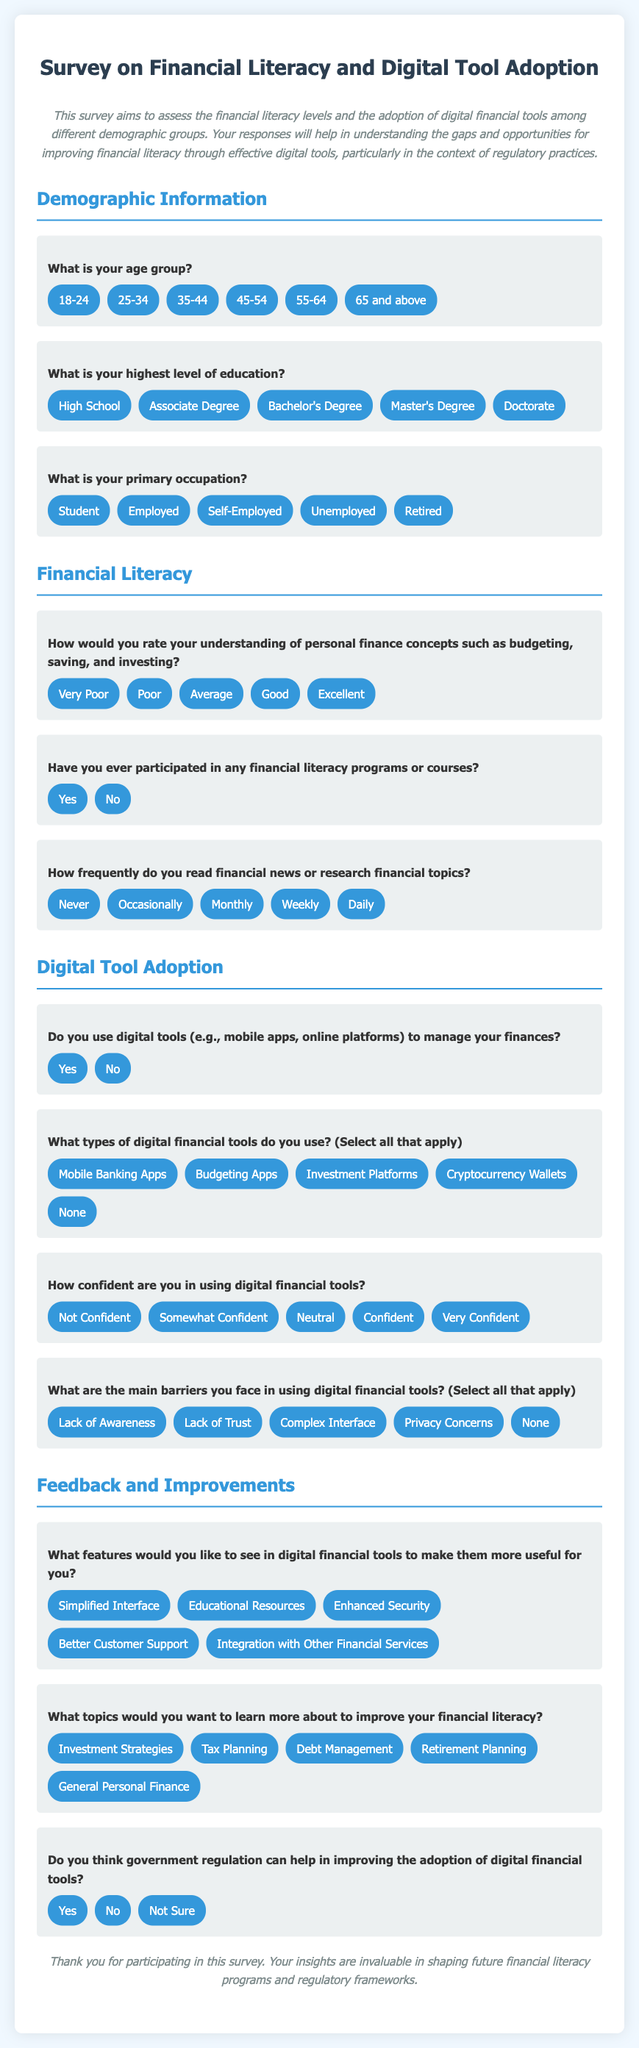What is the title of the document? The title of the document is displayed prominently at the top of the rendered survey and indicates the focus of the survey.
Answer: Survey on Financial Literacy and Digital Tool Adoption What color is the background of the document? The background color of the document is specified in the style section and is light blue.
Answer: Light blue How many age group options are provided in the survey? The document lists the age group options in the demographic section, and the number of options can be counted directly.
Answer: Six What are the two response options for financial literacy program participation? The document presents two clear choices in the survey question regarding participation in financial literacy programs.
Answer: Yes, No What type of feedback is requested regarding digital financial tools? The document asks participants for suggestions on features that could enhance digital financial tools, reflecting the aim for improvement.
Answer: Features How is the survey structured? The document breaks the survey into distinct sections, each focusing on a specific theme related to financial literacy or digital tool adoption.
Answer: Sections Do the options for confidence in using digital tools include a negative response? The survey clearly lists options for confidence levels; one of the options indicates a lack of confidence.
Answer: Not Confident What is the primary purpose of this survey? The introduction of the document states the purpose of the survey, which relates to assessing financial literacy and digital tool usage.
Answer: Assess financial literacy and digital tool adoption 